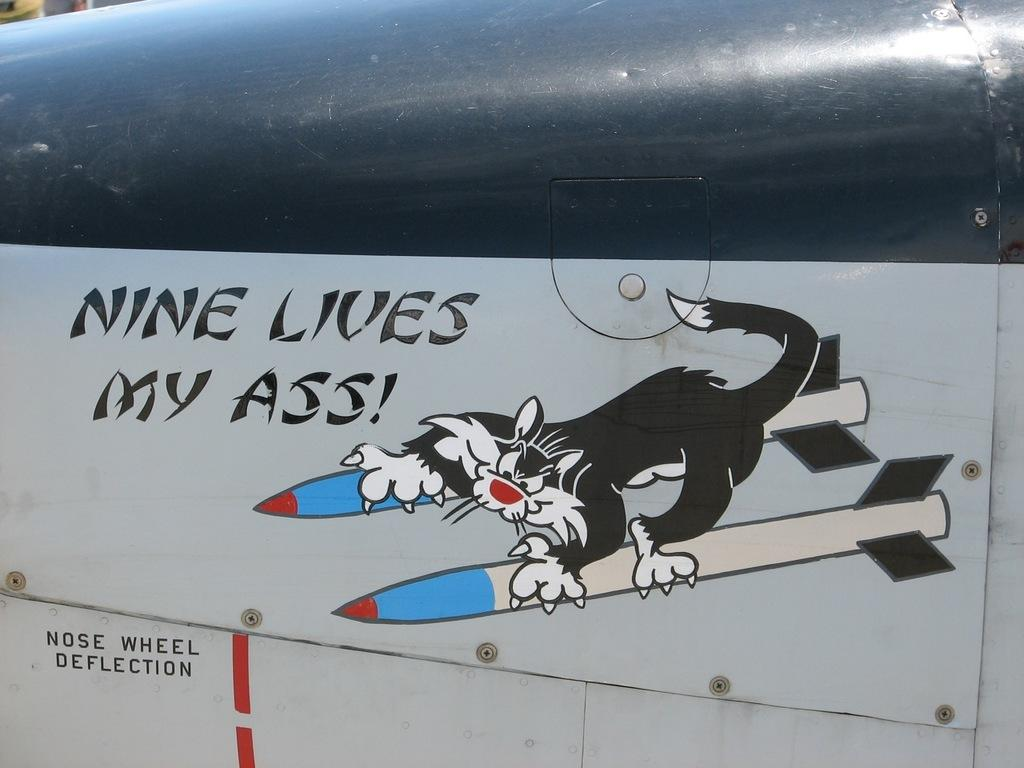What can be seen in the image besides the metal surface? There is text and art visible in the image. What is the medium or material on which the text and art are displayed? Both the text and art are on a metal surface. What type of toothpaste is being advertised in the image? There is no toothpaste present in the image. What level of respect is being promoted in the image? The image does not convey any specific message about respect. Is there any indication of a crime being committed in the image? There is no indication of a crime being committed in the image. 